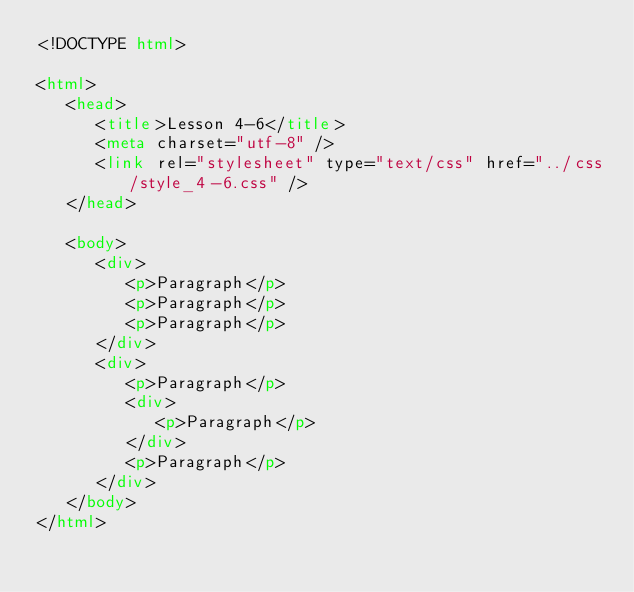Convert code to text. <code><loc_0><loc_0><loc_500><loc_500><_HTML_><!DOCTYPE html>

<html>
   <head>
      <title>Lesson 4-6</title>
      <meta charset="utf-8" />
      <link rel="stylesheet" type="text/css" href="../css/style_4-6.css" />
   </head>
   
   <body>
      <div>
         <p>Paragraph</p>
         <p>Paragraph</p>
         <p>Paragraph</p>
      </div>
      <div>
         <p>Paragraph</p>
         <div>
            <p>Paragraph</p>
         </div>
         <p>Paragraph</p>
      </div>
   </body>
</html>
</code> 